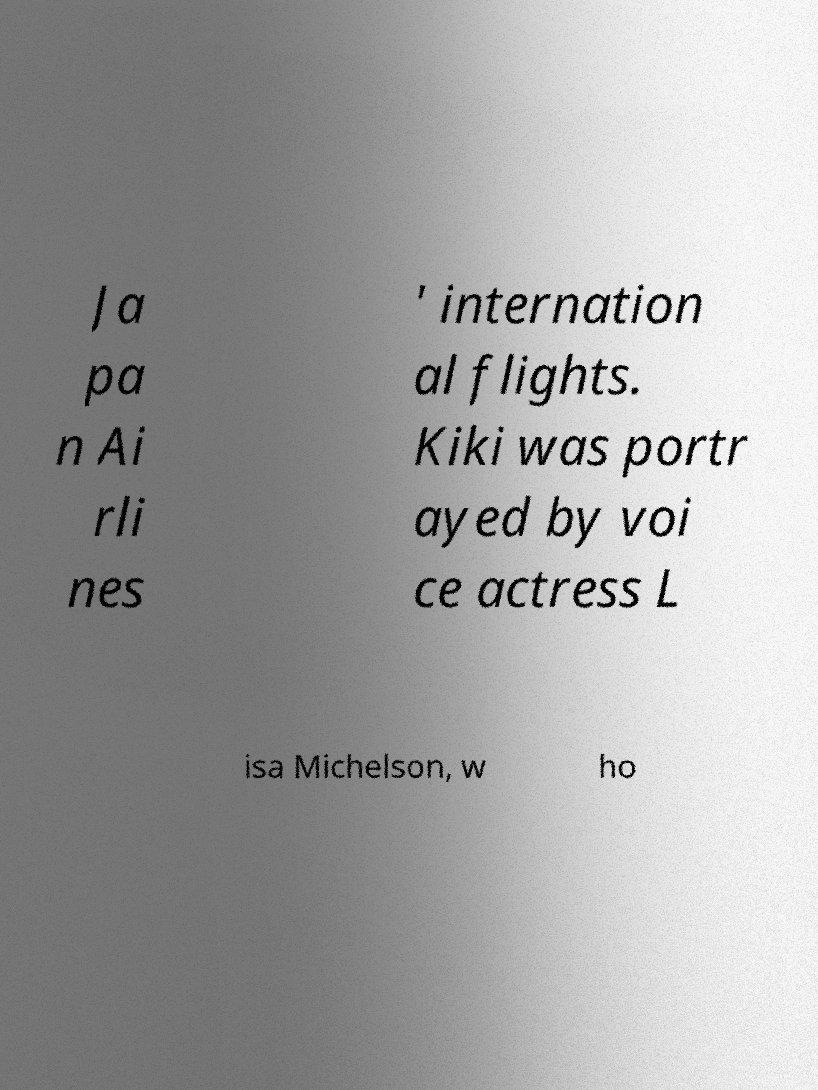There's text embedded in this image that I need extracted. Can you transcribe it verbatim? Ja pa n Ai rli nes ' internation al flights. Kiki was portr ayed by voi ce actress L isa Michelson, w ho 